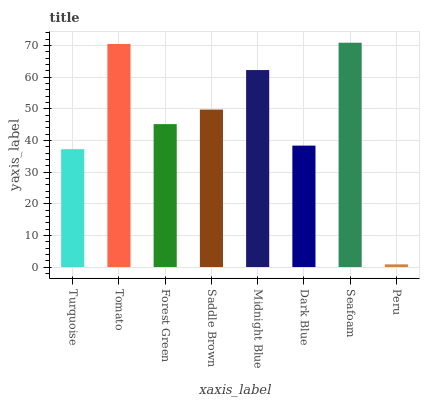Is Peru the minimum?
Answer yes or no. Yes. Is Seafoam the maximum?
Answer yes or no. Yes. Is Tomato the minimum?
Answer yes or no. No. Is Tomato the maximum?
Answer yes or no. No. Is Tomato greater than Turquoise?
Answer yes or no. Yes. Is Turquoise less than Tomato?
Answer yes or no. Yes. Is Turquoise greater than Tomato?
Answer yes or no. No. Is Tomato less than Turquoise?
Answer yes or no. No. Is Saddle Brown the high median?
Answer yes or no. Yes. Is Forest Green the low median?
Answer yes or no. Yes. Is Turquoise the high median?
Answer yes or no. No. Is Dark Blue the low median?
Answer yes or no. No. 